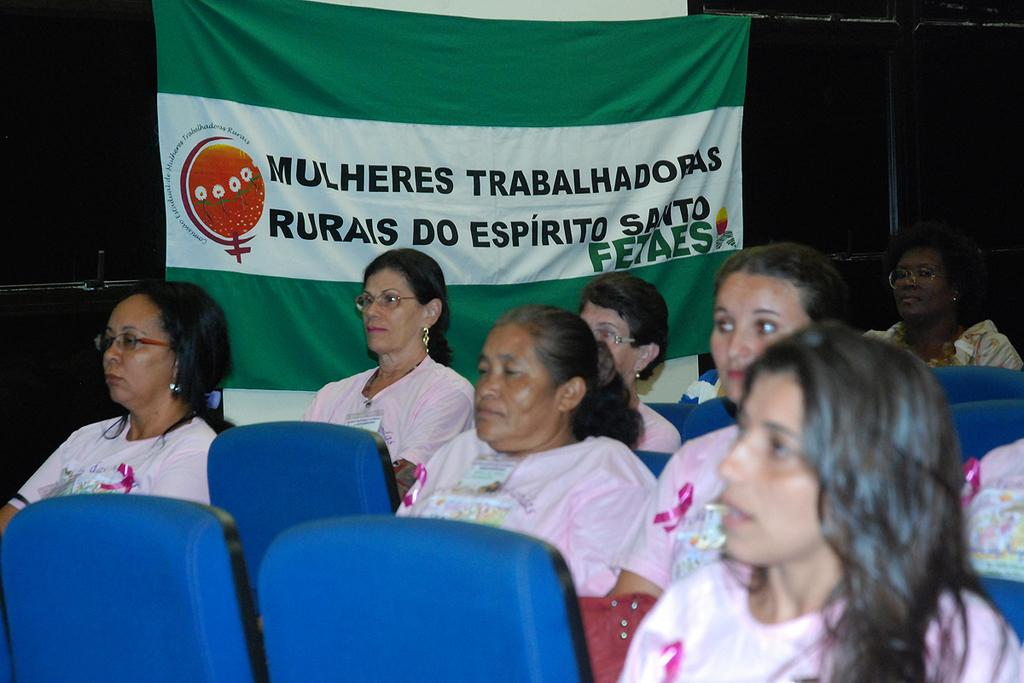Who is present in the image? There are people in the image. What are the people wearing? The people are wearing pink T-shirts. What are the people sitting on? The people are sitting on blue chairs. What can be seen in the background of the image? There is a banner in the background of the image. How would you describe the lighting in the image? The background appears to be dark. What type of slope can be seen in the image? There is no slope present in the image. What is the people's reaction to the shameful event in the image? There is no mention of a shameful event in the image; the people are simply sitting on blue chairs wearing pink T-shirts. 